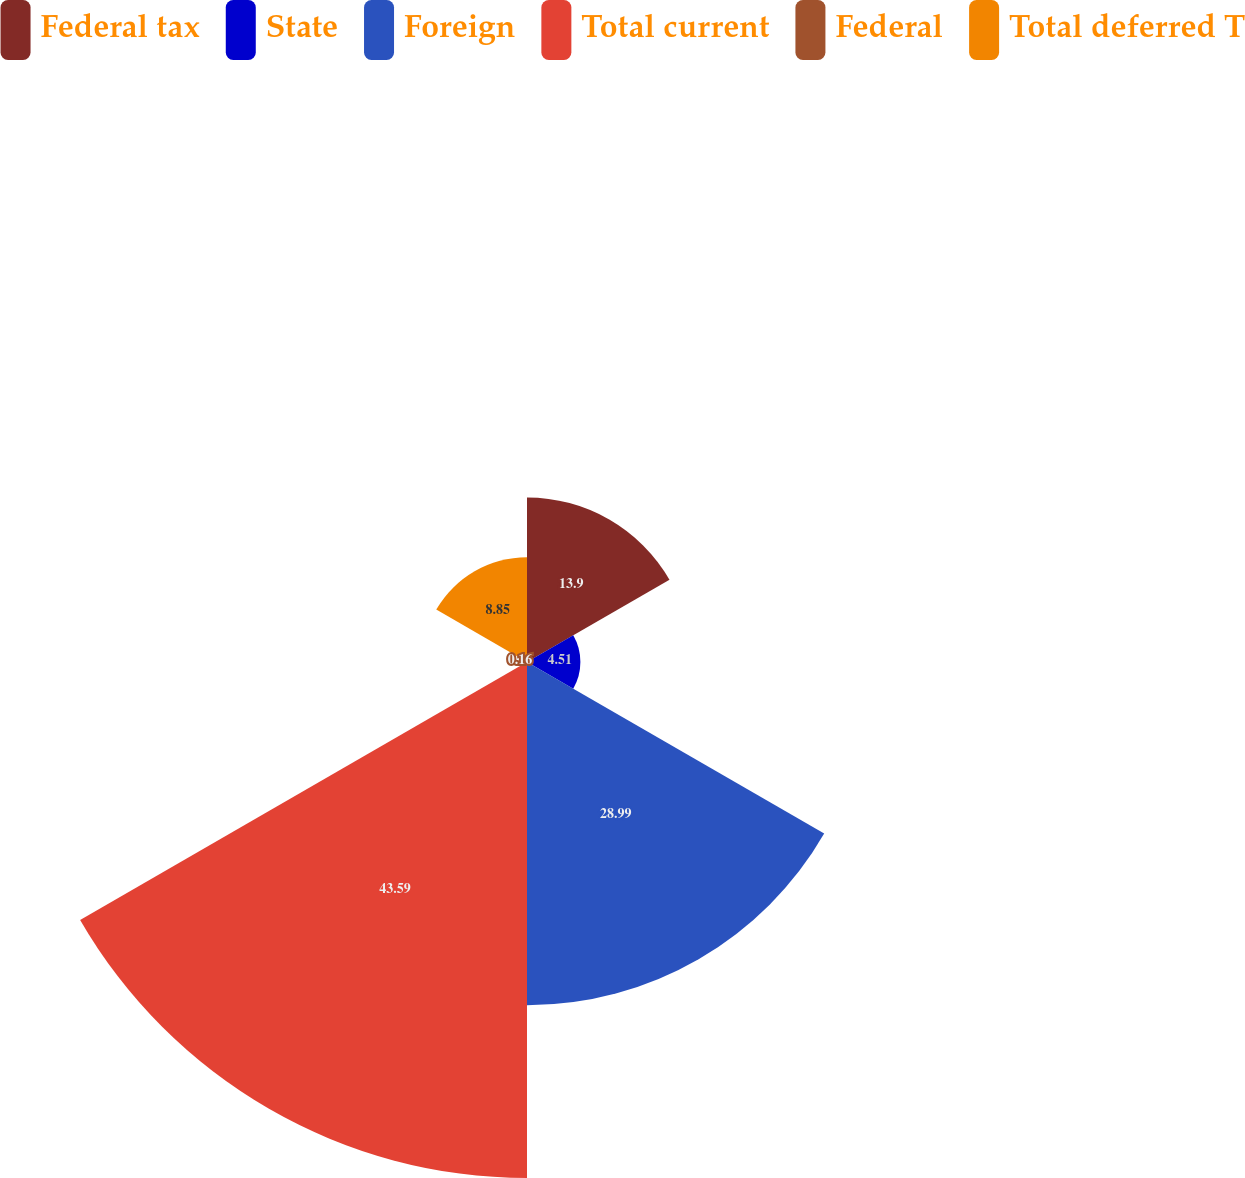Convert chart. <chart><loc_0><loc_0><loc_500><loc_500><pie_chart><fcel>Federal tax<fcel>State<fcel>Foreign<fcel>Total current<fcel>Federal<fcel>Total deferred T<nl><fcel>13.9%<fcel>4.51%<fcel>28.99%<fcel>43.59%<fcel>0.16%<fcel>8.85%<nl></chart> 